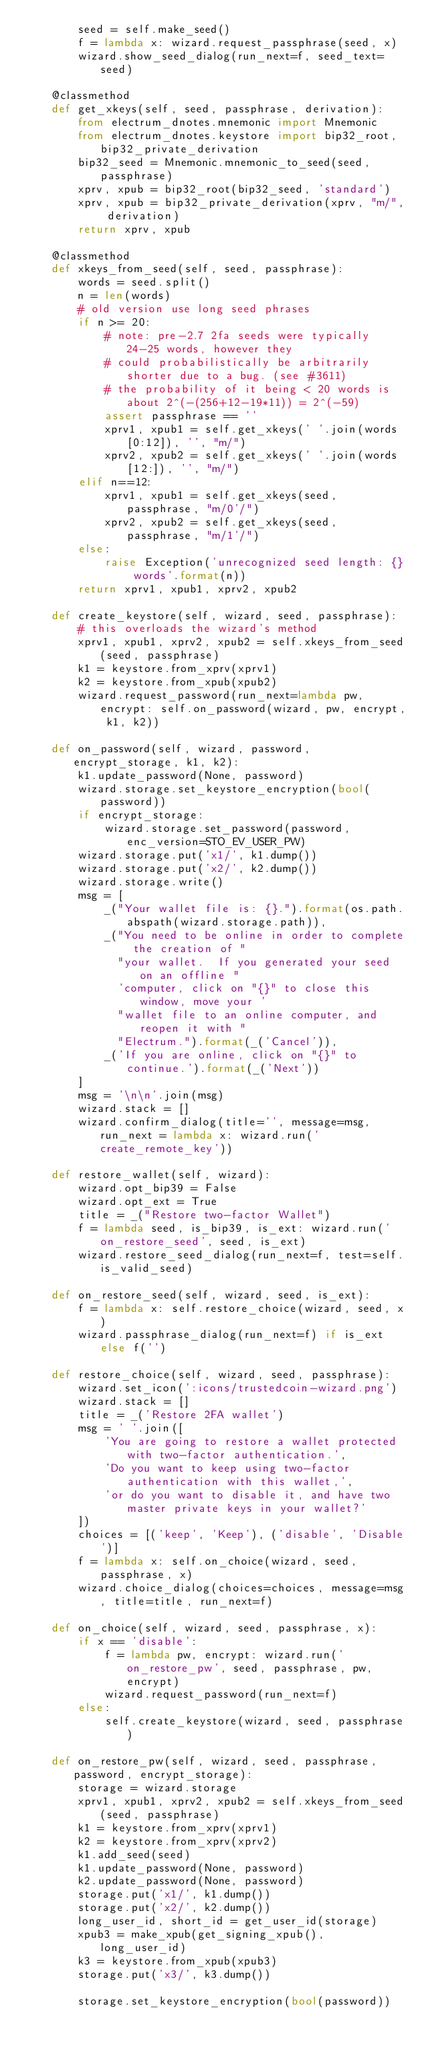<code> <loc_0><loc_0><loc_500><loc_500><_Python_>        seed = self.make_seed()
        f = lambda x: wizard.request_passphrase(seed, x)
        wizard.show_seed_dialog(run_next=f, seed_text=seed)

    @classmethod
    def get_xkeys(self, seed, passphrase, derivation):
        from electrum_dnotes.mnemonic import Mnemonic
        from electrum_dnotes.keystore import bip32_root, bip32_private_derivation
        bip32_seed = Mnemonic.mnemonic_to_seed(seed, passphrase)
        xprv, xpub = bip32_root(bip32_seed, 'standard')
        xprv, xpub = bip32_private_derivation(xprv, "m/", derivation)
        return xprv, xpub

    @classmethod
    def xkeys_from_seed(self, seed, passphrase):
        words = seed.split()
        n = len(words)
        # old version use long seed phrases
        if n >= 20:
            # note: pre-2.7 2fa seeds were typically 24-25 words, however they
            # could probabilistically be arbitrarily shorter due to a bug. (see #3611)
            # the probability of it being < 20 words is about 2^(-(256+12-19*11)) = 2^(-59)
            assert passphrase == ''
            xprv1, xpub1 = self.get_xkeys(' '.join(words[0:12]), '', "m/")
            xprv2, xpub2 = self.get_xkeys(' '.join(words[12:]), '', "m/")
        elif n==12:
            xprv1, xpub1 = self.get_xkeys(seed, passphrase, "m/0'/")
            xprv2, xpub2 = self.get_xkeys(seed, passphrase, "m/1'/")
        else:
            raise Exception('unrecognized seed length: {} words'.format(n))
        return xprv1, xpub1, xprv2, xpub2

    def create_keystore(self, wizard, seed, passphrase):
        # this overloads the wizard's method
        xprv1, xpub1, xprv2, xpub2 = self.xkeys_from_seed(seed, passphrase)
        k1 = keystore.from_xprv(xprv1)
        k2 = keystore.from_xpub(xpub2)
        wizard.request_password(run_next=lambda pw, encrypt: self.on_password(wizard, pw, encrypt, k1, k2))

    def on_password(self, wizard, password, encrypt_storage, k1, k2):
        k1.update_password(None, password)
        wizard.storage.set_keystore_encryption(bool(password))
        if encrypt_storage:
            wizard.storage.set_password(password, enc_version=STO_EV_USER_PW)
        wizard.storage.put('x1/', k1.dump())
        wizard.storage.put('x2/', k2.dump())
        wizard.storage.write()
        msg = [
            _("Your wallet file is: {}.").format(os.path.abspath(wizard.storage.path)),
            _("You need to be online in order to complete the creation of "
              "your wallet.  If you generated your seed on an offline "
              'computer, click on "{}" to close this window, move your '
              "wallet file to an online computer, and reopen it with "
              "Electrum.").format(_('Cancel')),
            _('If you are online, click on "{}" to continue.').format(_('Next'))
        ]
        msg = '\n\n'.join(msg)
        wizard.stack = []
        wizard.confirm_dialog(title='', message=msg, run_next = lambda x: wizard.run('create_remote_key'))

    def restore_wallet(self, wizard):
        wizard.opt_bip39 = False
        wizard.opt_ext = True
        title = _("Restore two-factor Wallet")
        f = lambda seed, is_bip39, is_ext: wizard.run('on_restore_seed', seed, is_ext)
        wizard.restore_seed_dialog(run_next=f, test=self.is_valid_seed)

    def on_restore_seed(self, wizard, seed, is_ext):
        f = lambda x: self.restore_choice(wizard, seed, x)
        wizard.passphrase_dialog(run_next=f) if is_ext else f('')

    def restore_choice(self, wizard, seed, passphrase):
        wizard.set_icon(':icons/trustedcoin-wizard.png')
        wizard.stack = []
        title = _('Restore 2FA wallet')
        msg = ' '.join([
            'You are going to restore a wallet protected with two-factor authentication.',
            'Do you want to keep using two-factor authentication with this wallet,',
            'or do you want to disable it, and have two master private keys in your wallet?'
        ])
        choices = [('keep', 'Keep'), ('disable', 'Disable')]
        f = lambda x: self.on_choice(wizard, seed, passphrase, x)
        wizard.choice_dialog(choices=choices, message=msg, title=title, run_next=f)

    def on_choice(self, wizard, seed, passphrase, x):
        if x == 'disable':
            f = lambda pw, encrypt: wizard.run('on_restore_pw', seed, passphrase, pw, encrypt)
            wizard.request_password(run_next=f)
        else:
            self.create_keystore(wizard, seed, passphrase)

    def on_restore_pw(self, wizard, seed, passphrase, password, encrypt_storage):
        storage = wizard.storage
        xprv1, xpub1, xprv2, xpub2 = self.xkeys_from_seed(seed, passphrase)
        k1 = keystore.from_xprv(xprv1)
        k2 = keystore.from_xprv(xprv2)
        k1.add_seed(seed)
        k1.update_password(None, password)
        k2.update_password(None, password)
        storage.put('x1/', k1.dump())
        storage.put('x2/', k2.dump())
        long_user_id, short_id = get_user_id(storage)
        xpub3 = make_xpub(get_signing_xpub(), long_user_id)
        k3 = keystore.from_xpub(xpub3)
        storage.put('x3/', k3.dump())

        storage.set_keystore_encryption(bool(password))</code> 